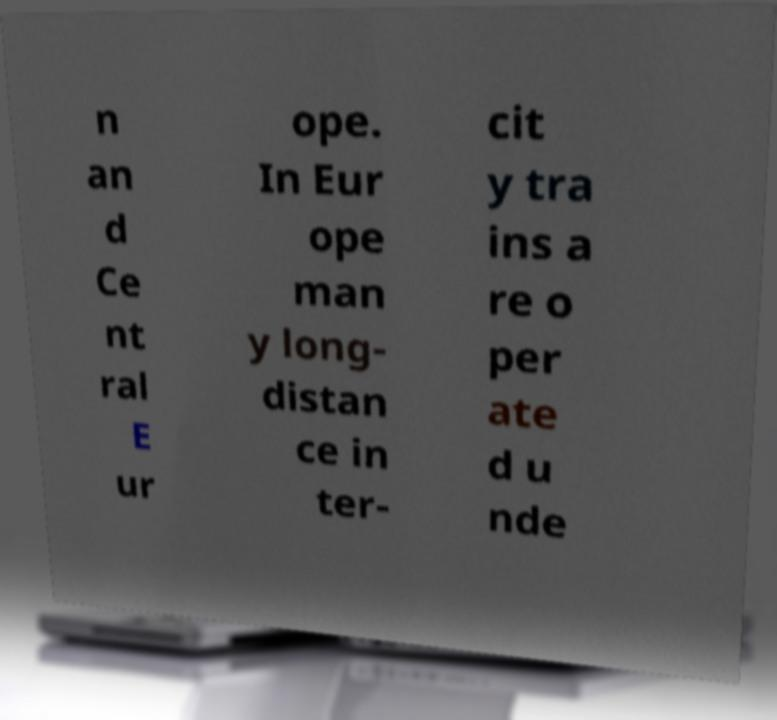Can you read and provide the text displayed in the image?This photo seems to have some interesting text. Can you extract and type it out for me? n an d Ce nt ral E ur ope. In Eur ope man y long- distan ce in ter- cit y tra ins a re o per ate d u nde 